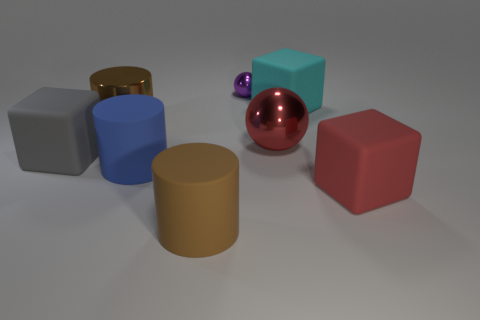How many things are either red matte things or cubes on the left side of the blue matte object?
Give a very brief answer. 2. The object that is to the left of the small purple sphere and right of the large blue cylinder is made of what material?
Ensure brevity in your answer.  Rubber. There is a sphere that is in front of the large brown shiny thing; what material is it?
Your response must be concise. Metal. What is the color of the other ball that is the same material as the small ball?
Keep it short and to the point. Red. There is a big brown matte thing; does it have the same shape as the red object behind the big gray thing?
Offer a terse response. No. Are there any rubber cylinders in front of the large sphere?
Offer a terse response. Yes. What is the material of the big object that is the same color as the large metallic ball?
Your answer should be compact. Rubber. Do the blue object and the brown thing in front of the large gray thing have the same size?
Offer a terse response. Yes. Are there any rubber cylinders of the same color as the small metal sphere?
Offer a very short reply. No. Is there a purple object that has the same shape as the large red rubber object?
Give a very brief answer. No. 